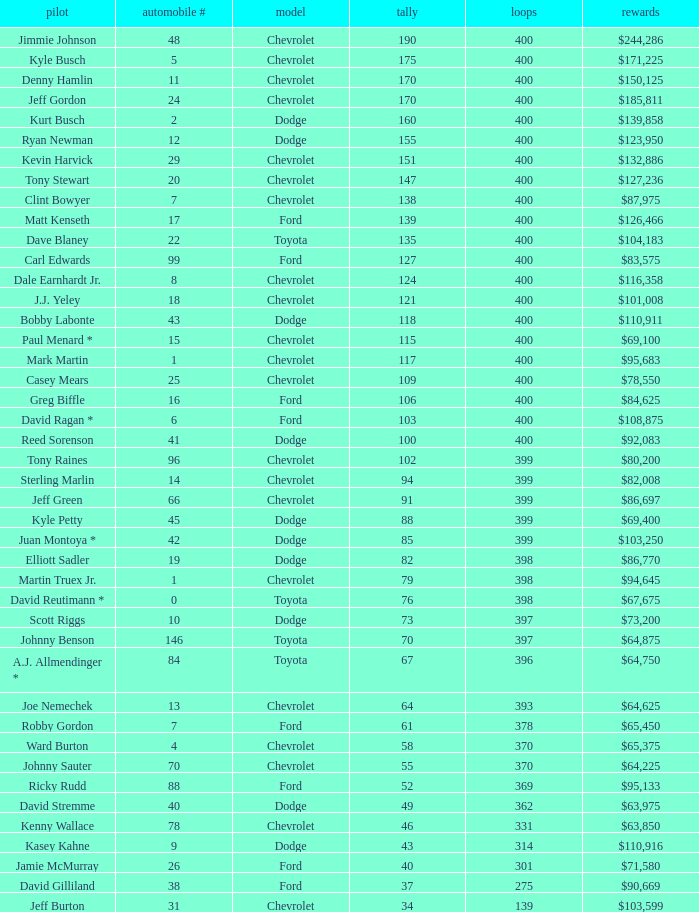What were the winnings for the Chevrolet with a number larger than 29 and scored 102 points? $80,200. 